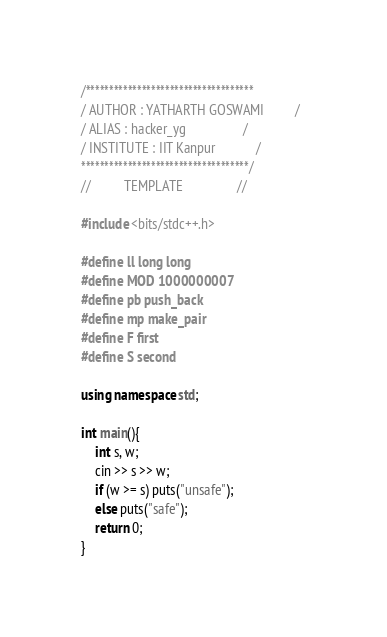Convert code to text. <code><loc_0><loc_0><loc_500><loc_500><_C++_>/************************************
/ AUTHOR : YATHARTH GOSWAMI         /  
/ ALIAS : hacker_yg                 /
/ INSTITUTE : IIT Kanpur            /
************************************/
//          TEMPLATE                //

#include <bits/stdc++.h>

#define ll long long
#define MOD 1000000007
#define pb push_back
#define mp make_pair
#define F first
#define S second

using namespace std;

int main(){
    int s, w;
    cin >> s >> w;
    if (w >= s) puts("unsafe");
    else puts("safe");
    return 0;
}


</code> 